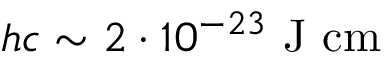Convert formula to latex. <formula><loc_0><loc_0><loc_500><loc_500>\ h c \sim 2 \cdot 1 0 ^ { - 2 3 } \ J \ c m</formula> 